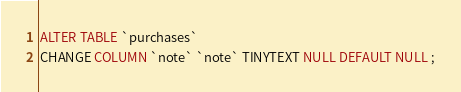Convert code to text. <code><loc_0><loc_0><loc_500><loc_500><_SQL_>ALTER TABLE `purchases` 
CHANGE COLUMN `note` `note` TINYTEXT NULL DEFAULT NULL ;
</code> 